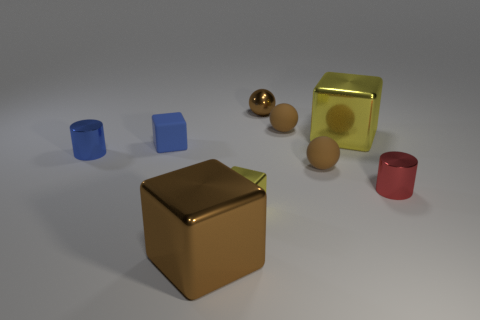Subtract all brown balls. How many were subtracted if there are1brown balls left? 2 Subtract all purple cylinders. Subtract all purple cubes. How many cylinders are left? 2 Subtract all blocks. How many objects are left? 5 Add 6 cubes. How many cubes are left? 10 Add 8 big shiny things. How many big shiny things exist? 10 Subtract 0 gray spheres. How many objects are left? 9 Subtract all small metal cylinders. Subtract all small brown metallic objects. How many objects are left? 6 